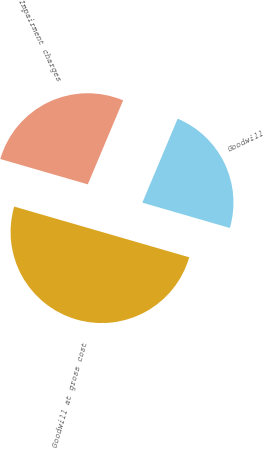Convert chart. <chart><loc_0><loc_0><loc_500><loc_500><pie_chart><fcel>Goodwill at gross cost<fcel>Impairment charges<fcel>Goodwill<nl><fcel>50.0%<fcel>26.85%<fcel>23.15%<nl></chart> 